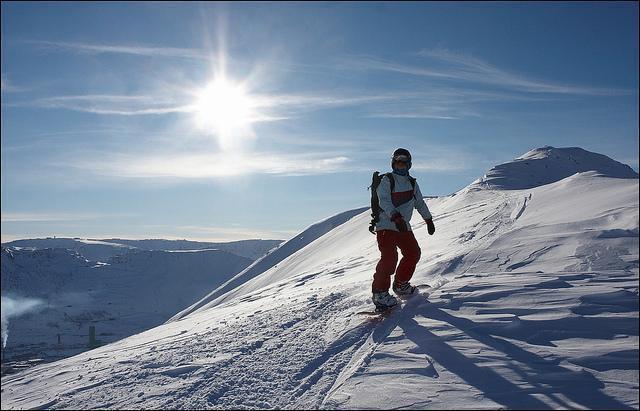Which direction will this person most likely go next?
Indicate the correct response by choosing from the four available options to answer the question.
Options: Down slop, skyward, same elevation, higher. Down slop. 